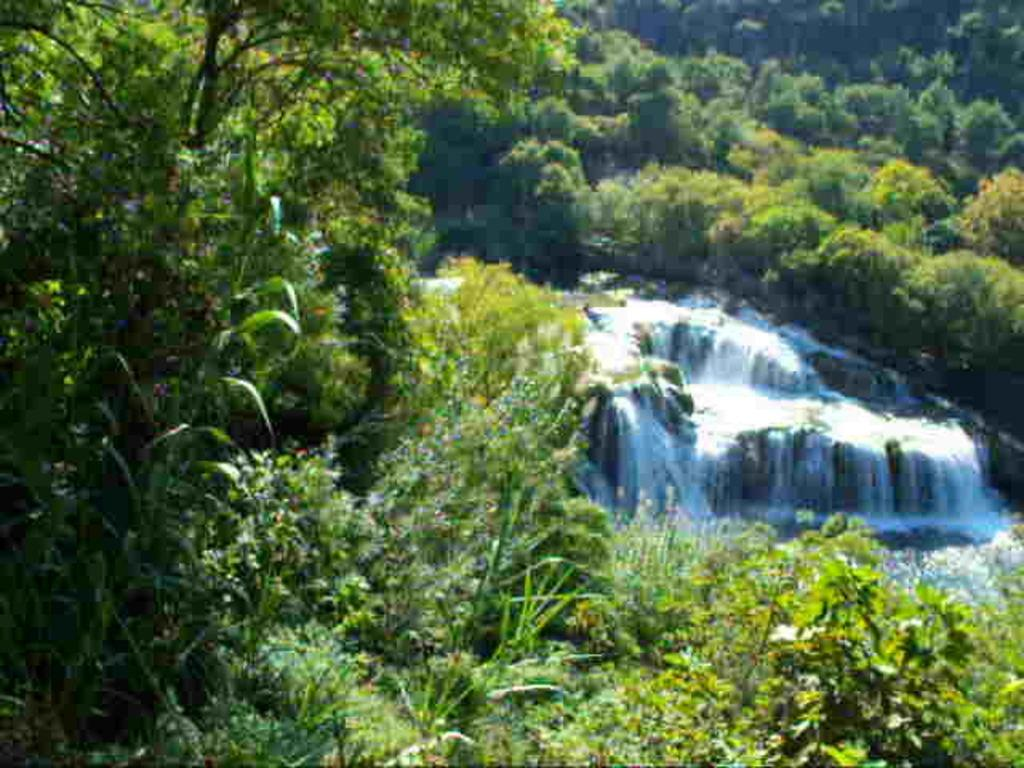What is the main feature in the center of the image? There is a waterfall in the center of the image. What can be seen surrounding the waterfall? There is greenery around the area of the image. What type of agreement is being signed in the image? There is no agreement or signing activity present in the image; it features a waterfall and greenery. What color is the hat worn by the person in the image? There is no person or hat present in the image; it features a waterfall and greenery. 